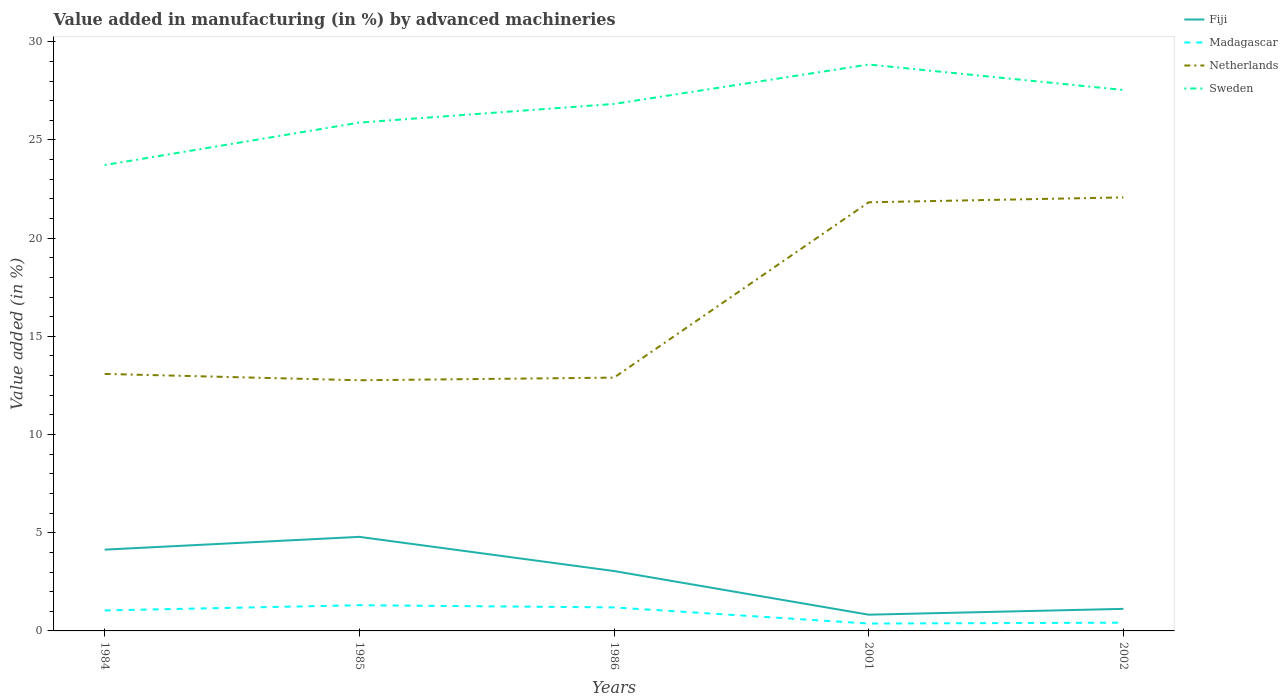How many different coloured lines are there?
Offer a terse response. 4. Does the line corresponding to Netherlands intersect with the line corresponding to Sweden?
Offer a very short reply. No. Is the number of lines equal to the number of legend labels?
Keep it short and to the point. Yes. Across all years, what is the maximum percentage of value added in manufacturing by advanced machineries in Madagascar?
Give a very brief answer. 0.38. What is the total percentage of value added in manufacturing by advanced machineries in Netherlands in the graph?
Offer a very short reply. -9.18. What is the difference between the highest and the second highest percentage of value added in manufacturing by advanced machineries in Madagascar?
Give a very brief answer. 0.93. How many lines are there?
Your answer should be compact. 4. How many years are there in the graph?
Provide a short and direct response. 5. Are the values on the major ticks of Y-axis written in scientific E-notation?
Ensure brevity in your answer.  No. Does the graph contain any zero values?
Your answer should be very brief. No. Does the graph contain grids?
Ensure brevity in your answer.  No. What is the title of the graph?
Your response must be concise. Value added in manufacturing (in %) by advanced machineries. Does "Argentina" appear as one of the legend labels in the graph?
Offer a terse response. No. What is the label or title of the Y-axis?
Your answer should be compact. Value added (in %). What is the Value added (in %) of Fiji in 1984?
Offer a very short reply. 4.14. What is the Value added (in %) in Madagascar in 1984?
Offer a very short reply. 1.04. What is the Value added (in %) of Netherlands in 1984?
Give a very brief answer. 13.09. What is the Value added (in %) in Sweden in 1984?
Your answer should be compact. 23.72. What is the Value added (in %) of Fiji in 1985?
Offer a terse response. 4.79. What is the Value added (in %) of Madagascar in 1985?
Your answer should be very brief. 1.31. What is the Value added (in %) of Netherlands in 1985?
Ensure brevity in your answer.  12.76. What is the Value added (in %) in Sweden in 1985?
Keep it short and to the point. 25.88. What is the Value added (in %) of Fiji in 1986?
Your answer should be compact. 3.05. What is the Value added (in %) of Madagascar in 1986?
Provide a succinct answer. 1.2. What is the Value added (in %) in Netherlands in 1986?
Offer a very short reply. 12.9. What is the Value added (in %) in Sweden in 1986?
Your answer should be very brief. 26.83. What is the Value added (in %) in Fiji in 2001?
Provide a succinct answer. 0.83. What is the Value added (in %) of Madagascar in 2001?
Make the answer very short. 0.38. What is the Value added (in %) of Netherlands in 2001?
Offer a very short reply. 21.83. What is the Value added (in %) in Sweden in 2001?
Give a very brief answer. 28.84. What is the Value added (in %) in Fiji in 2002?
Your answer should be very brief. 1.12. What is the Value added (in %) of Madagascar in 2002?
Offer a terse response. 0.42. What is the Value added (in %) in Netherlands in 2002?
Ensure brevity in your answer.  22.08. What is the Value added (in %) in Sweden in 2002?
Your answer should be compact. 27.54. Across all years, what is the maximum Value added (in %) in Fiji?
Offer a terse response. 4.79. Across all years, what is the maximum Value added (in %) of Madagascar?
Ensure brevity in your answer.  1.31. Across all years, what is the maximum Value added (in %) in Netherlands?
Provide a short and direct response. 22.08. Across all years, what is the maximum Value added (in %) of Sweden?
Provide a succinct answer. 28.84. Across all years, what is the minimum Value added (in %) in Fiji?
Offer a terse response. 0.83. Across all years, what is the minimum Value added (in %) of Madagascar?
Give a very brief answer. 0.38. Across all years, what is the minimum Value added (in %) in Netherlands?
Ensure brevity in your answer.  12.76. Across all years, what is the minimum Value added (in %) of Sweden?
Ensure brevity in your answer.  23.72. What is the total Value added (in %) in Fiji in the graph?
Offer a terse response. 13.93. What is the total Value added (in %) of Madagascar in the graph?
Your answer should be compact. 4.35. What is the total Value added (in %) in Netherlands in the graph?
Offer a very short reply. 82.65. What is the total Value added (in %) in Sweden in the graph?
Make the answer very short. 132.82. What is the difference between the Value added (in %) in Fiji in 1984 and that in 1985?
Your response must be concise. -0.65. What is the difference between the Value added (in %) of Madagascar in 1984 and that in 1985?
Keep it short and to the point. -0.27. What is the difference between the Value added (in %) in Netherlands in 1984 and that in 1985?
Provide a short and direct response. 0.32. What is the difference between the Value added (in %) in Sweden in 1984 and that in 1985?
Give a very brief answer. -2.16. What is the difference between the Value added (in %) of Fiji in 1984 and that in 1986?
Ensure brevity in your answer.  1.09. What is the difference between the Value added (in %) in Madagascar in 1984 and that in 1986?
Your answer should be compact. -0.15. What is the difference between the Value added (in %) in Netherlands in 1984 and that in 1986?
Offer a very short reply. 0.19. What is the difference between the Value added (in %) of Sweden in 1984 and that in 1986?
Your answer should be compact. -3.11. What is the difference between the Value added (in %) in Fiji in 1984 and that in 2001?
Provide a short and direct response. 3.31. What is the difference between the Value added (in %) in Madagascar in 1984 and that in 2001?
Keep it short and to the point. 0.67. What is the difference between the Value added (in %) of Netherlands in 1984 and that in 2001?
Your response must be concise. -8.74. What is the difference between the Value added (in %) of Sweden in 1984 and that in 2001?
Your response must be concise. -5.12. What is the difference between the Value added (in %) in Fiji in 1984 and that in 2002?
Your response must be concise. 3.02. What is the difference between the Value added (in %) of Madagascar in 1984 and that in 2002?
Offer a terse response. 0.62. What is the difference between the Value added (in %) of Netherlands in 1984 and that in 2002?
Provide a succinct answer. -8.99. What is the difference between the Value added (in %) in Sweden in 1984 and that in 2002?
Your answer should be compact. -3.82. What is the difference between the Value added (in %) of Fiji in 1985 and that in 1986?
Provide a short and direct response. 1.74. What is the difference between the Value added (in %) in Madagascar in 1985 and that in 1986?
Your response must be concise. 0.11. What is the difference between the Value added (in %) of Netherlands in 1985 and that in 1986?
Make the answer very short. -0.13. What is the difference between the Value added (in %) of Sweden in 1985 and that in 1986?
Your response must be concise. -0.95. What is the difference between the Value added (in %) in Fiji in 1985 and that in 2001?
Make the answer very short. 3.96. What is the difference between the Value added (in %) in Madagascar in 1985 and that in 2001?
Your answer should be very brief. 0.93. What is the difference between the Value added (in %) in Netherlands in 1985 and that in 2001?
Give a very brief answer. -9.06. What is the difference between the Value added (in %) of Sweden in 1985 and that in 2001?
Your answer should be very brief. -2.96. What is the difference between the Value added (in %) of Fiji in 1985 and that in 2002?
Offer a very short reply. 3.67. What is the difference between the Value added (in %) in Madagascar in 1985 and that in 2002?
Keep it short and to the point. 0.89. What is the difference between the Value added (in %) in Netherlands in 1985 and that in 2002?
Offer a very short reply. -9.31. What is the difference between the Value added (in %) in Sweden in 1985 and that in 2002?
Keep it short and to the point. -1.66. What is the difference between the Value added (in %) in Fiji in 1986 and that in 2001?
Your answer should be compact. 2.22. What is the difference between the Value added (in %) in Madagascar in 1986 and that in 2001?
Provide a succinct answer. 0.82. What is the difference between the Value added (in %) of Netherlands in 1986 and that in 2001?
Keep it short and to the point. -8.93. What is the difference between the Value added (in %) of Sweden in 1986 and that in 2001?
Your answer should be very brief. -2.01. What is the difference between the Value added (in %) in Fiji in 1986 and that in 2002?
Provide a succinct answer. 1.93. What is the difference between the Value added (in %) of Madagascar in 1986 and that in 2002?
Provide a short and direct response. 0.78. What is the difference between the Value added (in %) of Netherlands in 1986 and that in 2002?
Your answer should be compact. -9.18. What is the difference between the Value added (in %) of Sweden in 1986 and that in 2002?
Ensure brevity in your answer.  -0.71. What is the difference between the Value added (in %) of Fiji in 2001 and that in 2002?
Keep it short and to the point. -0.3. What is the difference between the Value added (in %) of Madagascar in 2001 and that in 2002?
Offer a terse response. -0.04. What is the difference between the Value added (in %) in Netherlands in 2001 and that in 2002?
Your answer should be very brief. -0.25. What is the difference between the Value added (in %) of Sweden in 2001 and that in 2002?
Your answer should be compact. 1.3. What is the difference between the Value added (in %) of Fiji in 1984 and the Value added (in %) of Madagascar in 1985?
Ensure brevity in your answer.  2.83. What is the difference between the Value added (in %) in Fiji in 1984 and the Value added (in %) in Netherlands in 1985?
Your answer should be compact. -8.62. What is the difference between the Value added (in %) of Fiji in 1984 and the Value added (in %) of Sweden in 1985?
Provide a short and direct response. -21.74. What is the difference between the Value added (in %) in Madagascar in 1984 and the Value added (in %) in Netherlands in 1985?
Your answer should be very brief. -11.72. What is the difference between the Value added (in %) of Madagascar in 1984 and the Value added (in %) of Sweden in 1985?
Your answer should be compact. -24.84. What is the difference between the Value added (in %) of Netherlands in 1984 and the Value added (in %) of Sweden in 1985?
Provide a succinct answer. -12.8. What is the difference between the Value added (in %) of Fiji in 1984 and the Value added (in %) of Madagascar in 1986?
Provide a short and direct response. 2.94. What is the difference between the Value added (in %) of Fiji in 1984 and the Value added (in %) of Netherlands in 1986?
Give a very brief answer. -8.76. What is the difference between the Value added (in %) in Fiji in 1984 and the Value added (in %) in Sweden in 1986?
Offer a terse response. -22.69. What is the difference between the Value added (in %) of Madagascar in 1984 and the Value added (in %) of Netherlands in 1986?
Your answer should be very brief. -11.85. What is the difference between the Value added (in %) of Madagascar in 1984 and the Value added (in %) of Sweden in 1986?
Offer a very short reply. -25.79. What is the difference between the Value added (in %) in Netherlands in 1984 and the Value added (in %) in Sweden in 1986?
Provide a succinct answer. -13.75. What is the difference between the Value added (in %) of Fiji in 1984 and the Value added (in %) of Madagascar in 2001?
Make the answer very short. 3.76. What is the difference between the Value added (in %) of Fiji in 1984 and the Value added (in %) of Netherlands in 2001?
Keep it short and to the point. -17.69. What is the difference between the Value added (in %) in Fiji in 1984 and the Value added (in %) in Sweden in 2001?
Your response must be concise. -24.7. What is the difference between the Value added (in %) in Madagascar in 1984 and the Value added (in %) in Netherlands in 2001?
Give a very brief answer. -20.78. What is the difference between the Value added (in %) of Madagascar in 1984 and the Value added (in %) of Sweden in 2001?
Provide a short and direct response. -27.8. What is the difference between the Value added (in %) in Netherlands in 1984 and the Value added (in %) in Sweden in 2001?
Provide a short and direct response. -15.75. What is the difference between the Value added (in %) in Fiji in 1984 and the Value added (in %) in Madagascar in 2002?
Make the answer very short. 3.72. What is the difference between the Value added (in %) in Fiji in 1984 and the Value added (in %) in Netherlands in 2002?
Offer a terse response. -17.94. What is the difference between the Value added (in %) of Fiji in 1984 and the Value added (in %) of Sweden in 2002?
Your answer should be very brief. -23.41. What is the difference between the Value added (in %) in Madagascar in 1984 and the Value added (in %) in Netherlands in 2002?
Offer a terse response. -21.03. What is the difference between the Value added (in %) in Madagascar in 1984 and the Value added (in %) in Sweden in 2002?
Provide a short and direct response. -26.5. What is the difference between the Value added (in %) in Netherlands in 1984 and the Value added (in %) in Sweden in 2002?
Offer a very short reply. -14.46. What is the difference between the Value added (in %) in Fiji in 1985 and the Value added (in %) in Madagascar in 1986?
Offer a very short reply. 3.59. What is the difference between the Value added (in %) of Fiji in 1985 and the Value added (in %) of Netherlands in 1986?
Your response must be concise. -8.11. What is the difference between the Value added (in %) in Fiji in 1985 and the Value added (in %) in Sweden in 1986?
Provide a succinct answer. -22.04. What is the difference between the Value added (in %) in Madagascar in 1985 and the Value added (in %) in Netherlands in 1986?
Your answer should be compact. -11.59. What is the difference between the Value added (in %) of Madagascar in 1985 and the Value added (in %) of Sweden in 1986?
Provide a short and direct response. -25.52. What is the difference between the Value added (in %) in Netherlands in 1985 and the Value added (in %) in Sweden in 1986?
Make the answer very short. -14.07. What is the difference between the Value added (in %) in Fiji in 1985 and the Value added (in %) in Madagascar in 2001?
Ensure brevity in your answer.  4.41. What is the difference between the Value added (in %) of Fiji in 1985 and the Value added (in %) of Netherlands in 2001?
Make the answer very short. -17.04. What is the difference between the Value added (in %) of Fiji in 1985 and the Value added (in %) of Sweden in 2001?
Provide a succinct answer. -24.05. What is the difference between the Value added (in %) in Madagascar in 1985 and the Value added (in %) in Netherlands in 2001?
Your answer should be compact. -20.52. What is the difference between the Value added (in %) in Madagascar in 1985 and the Value added (in %) in Sweden in 2001?
Provide a succinct answer. -27.53. What is the difference between the Value added (in %) in Netherlands in 1985 and the Value added (in %) in Sweden in 2001?
Your response must be concise. -16.08. What is the difference between the Value added (in %) in Fiji in 1985 and the Value added (in %) in Madagascar in 2002?
Keep it short and to the point. 4.37. What is the difference between the Value added (in %) of Fiji in 1985 and the Value added (in %) of Netherlands in 2002?
Give a very brief answer. -17.29. What is the difference between the Value added (in %) in Fiji in 1985 and the Value added (in %) in Sweden in 2002?
Keep it short and to the point. -22.75. What is the difference between the Value added (in %) of Madagascar in 1985 and the Value added (in %) of Netherlands in 2002?
Your answer should be compact. -20.77. What is the difference between the Value added (in %) in Madagascar in 1985 and the Value added (in %) in Sweden in 2002?
Make the answer very short. -26.24. What is the difference between the Value added (in %) in Netherlands in 1985 and the Value added (in %) in Sweden in 2002?
Give a very brief answer. -14.78. What is the difference between the Value added (in %) in Fiji in 1986 and the Value added (in %) in Madagascar in 2001?
Provide a succinct answer. 2.67. What is the difference between the Value added (in %) in Fiji in 1986 and the Value added (in %) in Netherlands in 2001?
Offer a very short reply. -18.78. What is the difference between the Value added (in %) of Fiji in 1986 and the Value added (in %) of Sweden in 2001?
Provide a short and direct response. -25.79. What is the difference between the Value added (in %) of Madagascar in 1986 and the Value added (in %) of Netherlands in 2001?
Offer a very short reply. -20.63. What is the difference between the Value added (in %) of Madagascar in 1986 and the Value added (in %) of Sweden in 2001?
Your response must be concise. -27.64. What is the difference between the Value added (in %) of Netherlands in 1986 and the Value added (in %) of Sweden in 2001?
Your answer should be very brief. -15.94. What is the difference between the Value added (in %) in Fiji in 1986 and the Value added (in %) in Madagascar in 2002?
Offer a very short reply. 2.63. What is the difference between the Value added (in %) of Fiji in 1986 and the Value added (in %) of Netherlands in 2002?
Your answer should be compact. -19.03. What is the difference between the Value added (in %) in Fiji in 1986 and the Value added (in %) in Sweden in 2002?
Offer a terse response. -24.49. What is the difference between the Value added (in %) in Madagascar in 1986 and the Value added (in %) in Netherlands in 2002?
Your answer should be compact. -20.88. What is the difference between the Value added (in %) in Madagascar in 1986 and the Value added (in %) in Sweden in 2002?
Your answer should be compact. -26.35. What is the difference between the Value added (in %) of Netherlands in 1986 and the Value added (in %) of Sweden in 2002?
Your answer should be very brief. -14.65. What is the difference between the Value added (in %) of Fiji in 2001 and the Value added (in %) of Madagascar in 2002?
Your answer should be compact. 0.41. What is the difference between the Value added (in %) of Fiji in 2001 and the Value added (in %) of Netherlands in 2002?
Offer a terse response. -21.25. What is the difference between the Value added (in %) in Fiji in 2001 and the Value added (in %) in Sweden in 2002?
Keep it short and to the point. -26.72. What is the difference between the Value added (in %) in Madagascar in 2001 and the Value added (in %) in Netherlands in 2002?
Your response must be concise. -21.7. What is the difference between the Value added (in %) in Madagascar in 2001 and the Value added (in %) in Sweden in 2002?
Your response must be concise. -27.17. What is the difference between the Value added (in %) of Netherlands in 2001 and the Value added (in %) of Sweden in 2002?
Offer a terse response. -5.72. What is the average Value added (in %) of Fiji per year?
Your answer should be very brief. 2.79. What is the average Value added (in %) of Madagascar per year?
Provide a short and direct response. 0.87. What is the average Value added (in %) in Netherlands per year?
Offer a very short reply. 16.53. What is the average Value added (in %) of Sweden per year?
Your response must be concise. 26.56. In the year 1984, what is the difference between the Value added (in %) in Fiji and Value added (in %) in Madagascar?
Ensure brevity in your answer.  3.09. In the year 1984, what is the difference between the Value added (in %) in Fiji and Value added (in %) in Netherlands?
Keep it short and to the point. -8.95. In the year 1984, what is the difference between the Value added (in %) of Fiji and Value added (in %) of Sweden?
Ensure brevity in your answer.  -19.58. In the year 1984, what is the difference between the Value added (in %) in Madagascar and Value added (in %) in Netherlands?
Keep it short and to the point. -12.04. In the year 1984, what is the difference between the Value added (in %) in Madagascar and Value added (in %) in Sweden?
Offer a very short reply. -22.68. In the year 1984, what is the difference between the Value added (in %) in Netherlands and Value added (in %) in Sweden?
Ensure brevity in your answer.  -10.63. In the year 1985, what is the difference between the Value added (in %) of Fiji and Value added (in %) of Madagascar?
Offer a very short reply. 3.48. In the year 1985, what is the difference between the Value added (in %) of Fiji and Value added (in %) of Netherlands?
Keep it short and to the point. -7.97. In the year 1985, what is the difference between the Value added (in %) in Fiji and Value added (in %) in Sweden?
Your response must be concise. -21.09. In the year 1985, what is the difference between the Value added (in %) of Madagascar and Value added (in %) of Netherlands?
Ensure brevity in your answer.  -11.45. In the year 1985, what is the difference between the Value added (in %) in Madagascar and Value added (in %) in Sweden?
Offer a very short reply. -24.57. In the year 1985, what is the difference between the Value added (in %) of Netherlands and Value added (in %) of Sweden?
Your answer should be compact. -13.12. In the year 1986, what is the difference between the Value added (in %) of Fiji and Value added (in %) of Madagascar?
Give a very brief answer. 1.85. In the year 1986, what is the difference between the Value added (in %) in Fiji and Value added (in %) in Netherlands?
Offer a very short reply. -9.85. In the year 1986, what is the difference between the Value added (in %) in Fiji and Value added (in %) in Sweden?
Your response must be concise. -23.78. In the year 1986, what is the difference between the Value added (in %) in Madagascar and Value added (in %) in Netherlands?
Keep it short and to the point. -11.7. In the year 1986, what is the difference between the Value added (in %) of Madagascar and Value added (in %) of Sweden?
Your response must be concise. -25.64. In the year 1986, what is the difference between the Value added (in %) in Netherlands and Value added (in %) in Sweden?
Your answer should be very brief. -13.94. In the year 2001, what is the difference between the Value added (in %) of Fiji and Value added (in %) of Madagascar?
Offer a terse response. 0.45. In the year 2001, what is the difference between the Value added (in %) in Fiji and Value added (in %) in Netherlands?
Offer a very short reply. -21. In the year 2001, what is the difference between the Value added (in %) of Fiji and Value added (in %) of Sweden?
Your answer should be very brief. -28.01. In the year 2001, what is the difference between the Value added (in %) of Madagascar and Value added (in %) of Netherlands?
Make the answer very short. -21.45. In the year 2001, what is the difference between the Value added (in %) in Madagascar and Value added (in %) in Sweden?
Offer a terse response. -28.46. In the year 2001, what is the difference between the Value added (in %) in Netherlands and Value added (in %) in Sweden?
Ensure brevity in your answer.  -7.01. In the year 2002, what is the difference between the Value added (in %) in Fiji and Value added (in %) in Madagascar?
Give a very brief answer. 0.7. In the year 2002, what is the difference between the Value added (in %) in Fiji and Value added (in %) in Netherlands?
Your answer should be compact. -20.95. In the year 2002, what is the difference between the Value added (in %) of Fiji and Value added (in %) of Sweden?
Provide a short and direct response. -26.42. In the year 2002, what is the difference between the Value added (in %) of Madagascar and Value added (in %) of Netherlands?
Keep it short and to the point. -21.66. In the year 2002, what is the difference between the Value added (in %) of Madagascar and Value added (in %) of Sweden?
Give a very brief answer. -27.12. In the year 2002, what is the difference between the Value added (in %) in Netherlands and Value added (in %) in Sweden?
Make the answer very short. -5.47. What is the ratio of the Value added (in %) of Fiji in 1984 to that in 1985?
Your answer should be compact. 0.86. What is the ratio of the Value added (in %) of Madagascar in 1984 to that in 1985?
Your answer should be compact. 0.8. What is the ratio of the Value added (in %) in Netherlands in 1984 to that in 1985?
Your answer should be compact. 1.03. What is the ratio of the Value added (in %) in Sweden in 1984 to that in 1985?
Your answer should be very brief. 0.92. What is the ratio of the Value added (in %) in Fiji in 1984 to that in 1986?
Ensure brevity in your answer.  1.36. What is the ratio of the Value added (in %) in Madagascar in 1984 to that in 1986?
Provide a succinct answer. 0.87. What is the ratio of the Value added (in %) of Netherlands in 1984 to that in 1986?
Provide a short and direct response. 1.01. What is the ratio of the Value added (in %) of Sweden in 1984 to that in 1986?
Keep it short and to the point. 0.88. What is the ratio of the Value added (in %) of Fiji in 1984 to that in 2001?
Keep it short and to the point. 5.01. What is the ratio of the Value added (in %) of Madagascar in 1984 to that in 2001?
Keep it short and to the point. 2.78. What is the ratio of the Value added (in %) in Netherlands in 1984 to that in 2001?
Make the answer very short. 0.6. What is the ratio of the Value added (in %) in Sweden in 1984 to that in 2001?
Provide a short and direct response. 0.82. What is the ratio of the Value added (in %) in Fiji in 1984 to that in 2002?
Ensure brevity in your answer.  3.68. What is the ratio of the Value added (in %) in Madagascar in 1984 to that in 2002?
Offer a terse response. 2.49. What is the ratio of the Value added (in %) in Netherlands in 1984 to that in 2002?
Provide a succinct answer. 0.59. What is the ratio of the Value added (in %) in Sweden in 1984 to that in 2002?
Make the answer very short. 0.86. What is the ratio of the Value added (in %) in Fiji in 1985 to that in 1986?
Make the answer very short. 1.57. What is the ratio of the Value added (in %) of Madagascar in 1985 to that in 1986?
Give a very brief answer. 1.09. What is the ratio of the Value added (in %) in Sweden in 1985 to that in 1986?
Your answer should be compact. 0.96. What is the ratio of the Value added (in %) of Fiji in 1985 to that in 2001?
Provide a succinct answer. 5.79. What is the ratio of the Value added (in %) in Madagascar in 1985 to that in 2001?
Your response must be concise. 3.48. What is the ratio of the Value added (in %) of Netherlands in 1985 to that in 2001?
Provide a short and direct response. 0.58. What is the ratio of the Value added (in %) in Sweden in 1985 to that in 2001?
Offer a terse response. 0.9. What is the ratio of the Value added (in %) in Fiji in 1985 to that in 2002?
Provide a short and direct response. 4.26. What is the ratio of the Value added (in %) of Madagascar in 1985 to that in 2002?
Keep it short and to the point. 3.12. What is the ratio of the Value added (in %) in Netherlands in 1985 to that in 2002?
Keep it short and to the point. 0.58. What is the ratio of the Value added (in %) in Sweden in 1985 to that in 2002?
Ensure brevity in your answer.  0.94. What is the ratio of the Value added (in %) of Fiji in 1986 to that in 2001?
Ensure brevity in your answer.  3.69. What is the ratio of the Value added (in %) of Madagascar in 1986 to that in 2001?
Make the answer very short. 3.18. What is the ratio of the Value added (in %) in Netherlands in 1986 to that in 2001?
Provide a succinct answer. 0.59. What is the ratio of the Value added (in %) of Sweden in 1986 to that in 2001?
Your response must be concise. 0.93. What is the ratio of the Value added (in %) of Fiji in 1986 to that in 2002?
Your response must be concise. 2.72. What is the ratio of the Value added (in %) of Madagascar in 1986 to that in 2002?
Your answer should be very brief. 2.85. What is the ratio of the Value added (in %) of Netherlands in 1986 to that in 2002?
Give a very brief answer. 0.58. What is the ratio of the Value added (in %) of Sweden in 1986 to that in 2002?
Provide a short and direct response. 0.97. What is the ratio of the Value added (in %) in Fiji in 2001 to that in 2002?
Make the answer very short. 0.74. What is the ratio of the Value added (in %) of Madagascar in 2001 to that in 2002?
Offer a very short reply. 0.9. What is the ratio of the Value added (in %) of Netherlands in 2001 to that in 2002?
Keep it short and to the point. 0.99. What is the ratio of the Value added (in %) in Sweden in 2001 to that in 2002?
Your answer should be very brief. 1.05. What is the difference between the highest and the second highest Value added (in %) of Fiji?
Offer a very short reply. 0.65. What is the difference between the highest and the second highest Value added (in %) in Madagascar?
Provide a short and direct response. 0.11. What is the difference between the highest and the second highest Value added (in %) of Netherlands?
Offer a very short reply. 0.25. What is the difference between the highest and the second highest Value added (in %) in Sweden?
Ensure brevity in your answer.  1.3. What is the difference between the highest and the lowest Value added (in %) of Fiji?
Your response must be concise. 3.96. What is the difference between the highest and the lowest Value added (in %) in Madagascar?
Your answer should be very brief. 0.93. What is the difference between the highest and the lowest Value added (in %) of Netherlands?
Your response must be concise. 9.31. What is the difference between the highest and the lowest Value added (in %) in Sweden?
Keep it short and to the point. 5.12. 